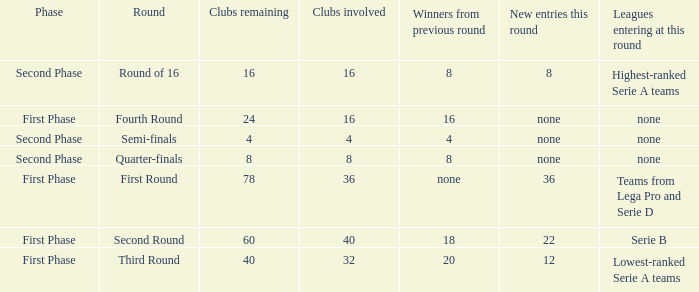When looking at new entries this round and seeing 8; what number in total is there for clubs remaining? 1.0. 